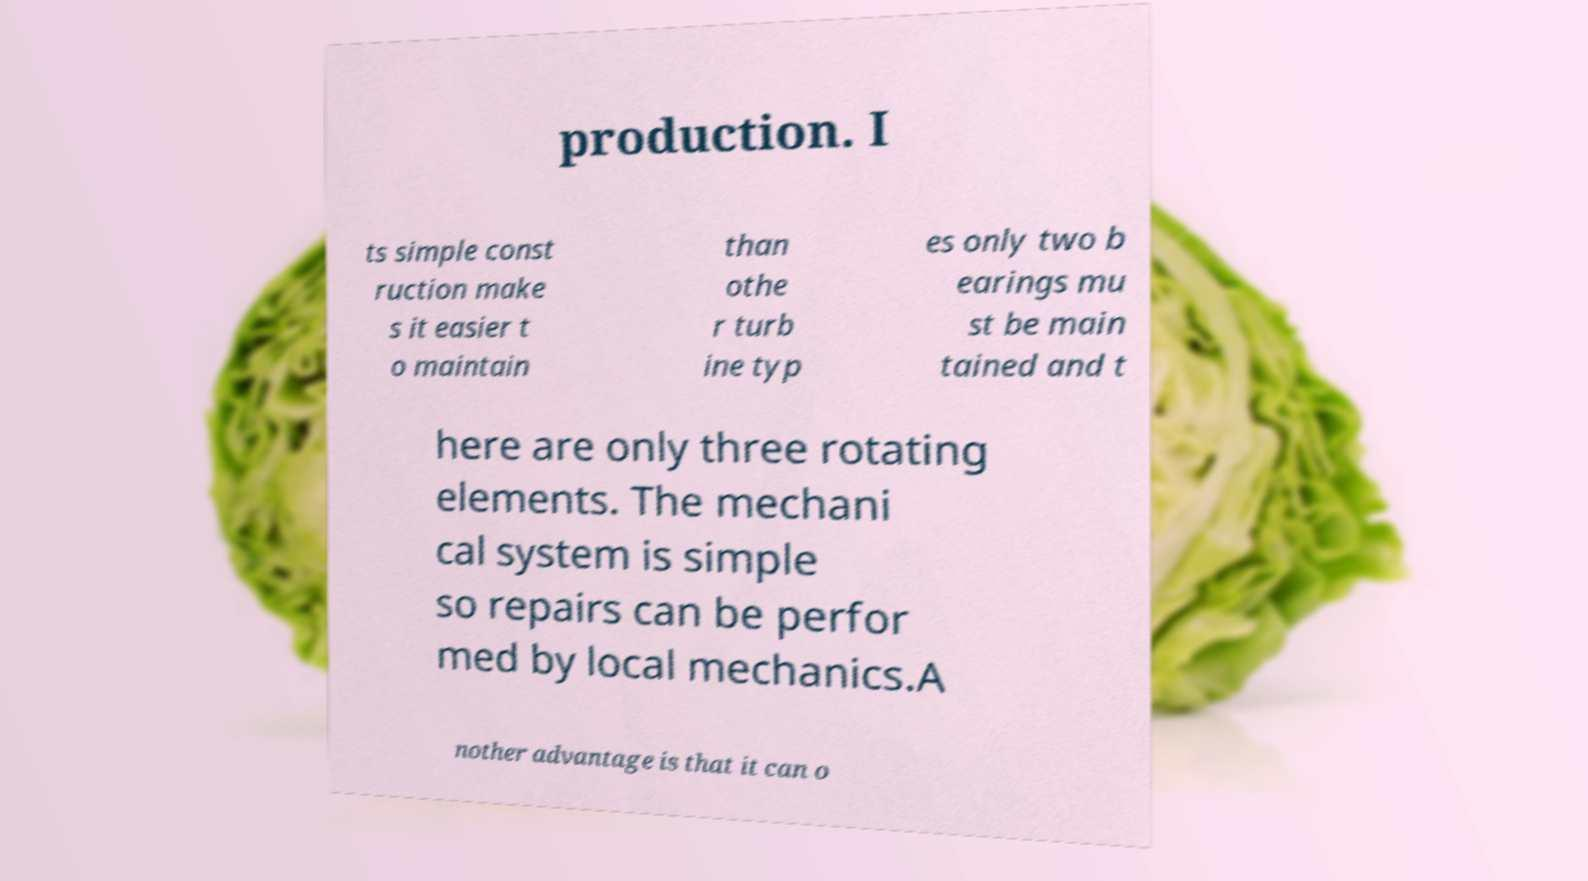For documentation purposes, I need the text within this image transcribed. Could you provide that? production. I ts simple const ruction make s it easier t o maintain than othe r turb ine typ es only two b earings mu st be main tained and t here are only three rotating elements. The mechani cal system is simple so repairs can be perfor med by local mechanics.A nother advantage is that it can o 